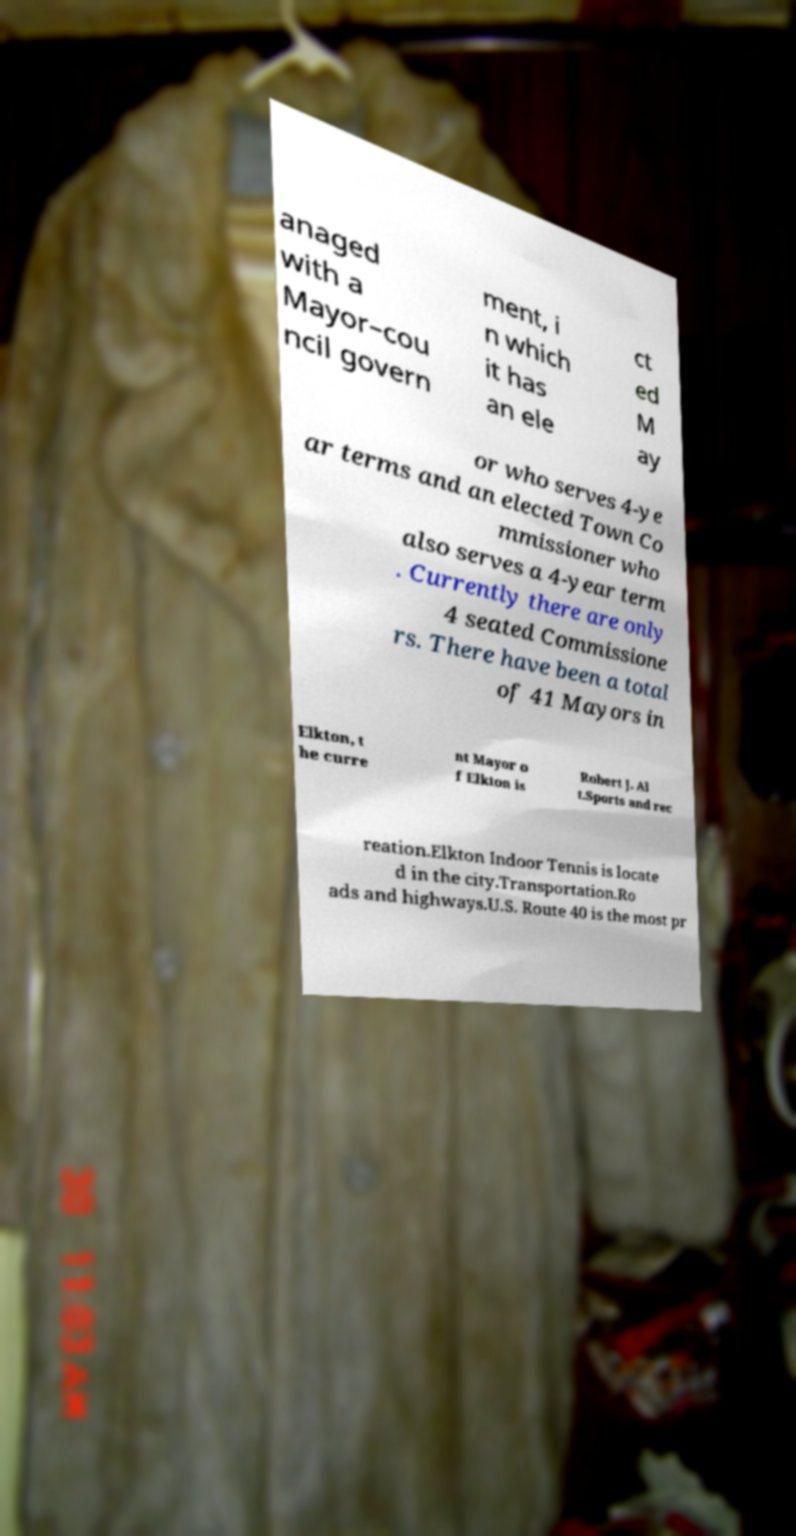What messages or text are displayed in this image? I need them in a readable, typed format. anaged with a Mayor–cou ncil govern ment, i n which it has an ele ct ed M ay or who serves 4-ye ar terms and an elected Town Co mmissioner who also serves a 4-year term . Currently there are only 4 seated Commissione rs. There have been a total of 41 Mayors in Elkton, t he curre nt Mayor o f Elkton is Robert J. Al t.Sports and rec reation.Elkton Indoor Tennis is locate d in the city.Transportation.Ro ads and highways.U.S. Route 40 is the most pr 